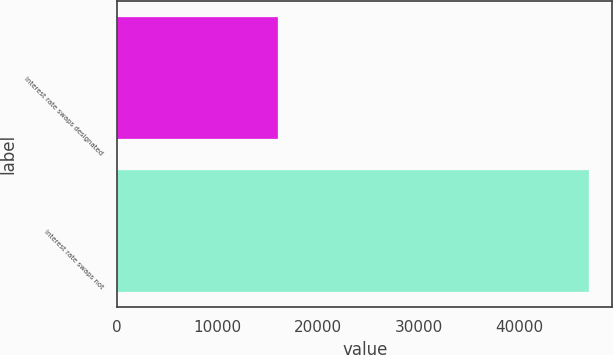Convert chart to OTSL. <chart><loc_0><loc_0><loc_500><loc_500><bar_chart><fcel>Interest rate swaps designated<fcel>Interest rate swaps not<nl><fcel>16048<fcel>46952<nl></chart> 